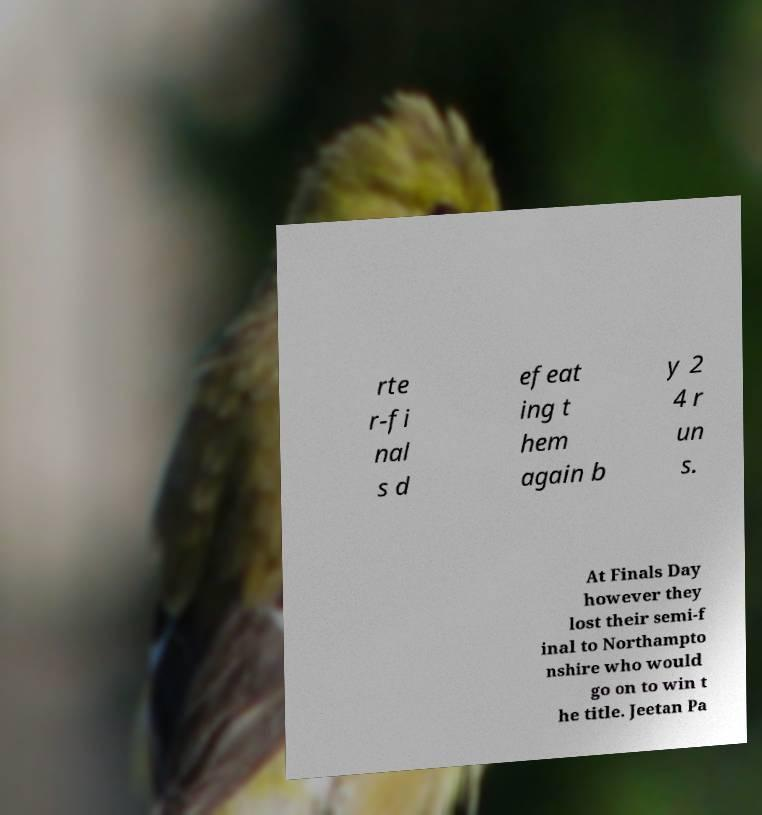Please identify and transcribe the text found in this image. rte r-fi nal s d efeat ing t hem again b y 2 4 r un s. At Finals Day however they lost their semi-f inal to Northampto nshire who would go on to win t he title. Jeetan Pa 